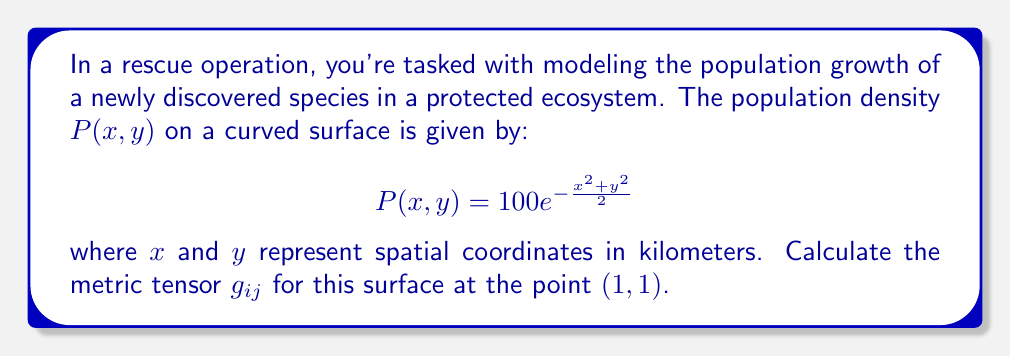Help me with this question. To find the metric tensor of this curved surface, we'll follow these steps:

1) The general form of a metric tensor for a 2D surface is:

   $$g_{ij} = \begin{pmatrix}
   g_{11} & g_{12} \\
   g_{21} & g_{22}
   \end{pmatrix}$$

2) For a surface defined by $z = f(x,y)$, the components of the metric tensor are:

   $$g_{11} = 1 + (\frac{\partial z}{\partial x})^2$$
   $$g_{12} = g_{21} = \frac{\partial z}{\partial x}\frac{\partial z}{\partial y}$$
   $$g_{22} = 1 + (\frac{\partial z}{\partial y})^2$$

3) In our case, $z = P(x,y) = 100e^{-\frac{x^2+y^2}{2}}$. Let's calculate the partial derivatives:

   $$\frac{\partial z}{\partial x} = -100xe^{-\frac{x^2+y^2}{2}}$$
   $$\frac{\partial z}{\partial y} = -100ye^{-\frac{x^2+y^2}{2}}$$

4) Now, let's evaluate these at the point (1,1):

   $$\left.\frac{\partial z}{\partial x}\right|_{(1,1)} = -100e^{-1}$$
   $$\left.\frac{\partial z}{\partial y}\right|_{(1,1)} = -100e^{-1}$$

5) We can now calculate the components of the metric tensor:

   $$g_{11} = 1 + (-100e^{-1})^2 = 1 + 10000e^{-2}$$
   $$g_{12} = g_{21} = (-100e^{-1})(-100e^{-1}) = 10000e^{-2}$$
   $$g_{22} = 1 + (-100e^{-1})^2 = 1 + 10000e^{-2}$$

6) Therefore, the metric tensor at (1,1) is:

   $$g_{ij} = \begin{pmatrix}
   1 + 10000e^{-2} & 10000e^{-2} \\
   10000e^{-2} & 1 + 10000e^{-2}
   \end{pmatrix}$$
Answer: $$g_{ij} = \begin{pmatrix}
1 + 10000e^{-2} & 10000e^{-2} \\
10000e^{-2} & 1 + 10000e^{-2}
\end{pmatrix}$$ 